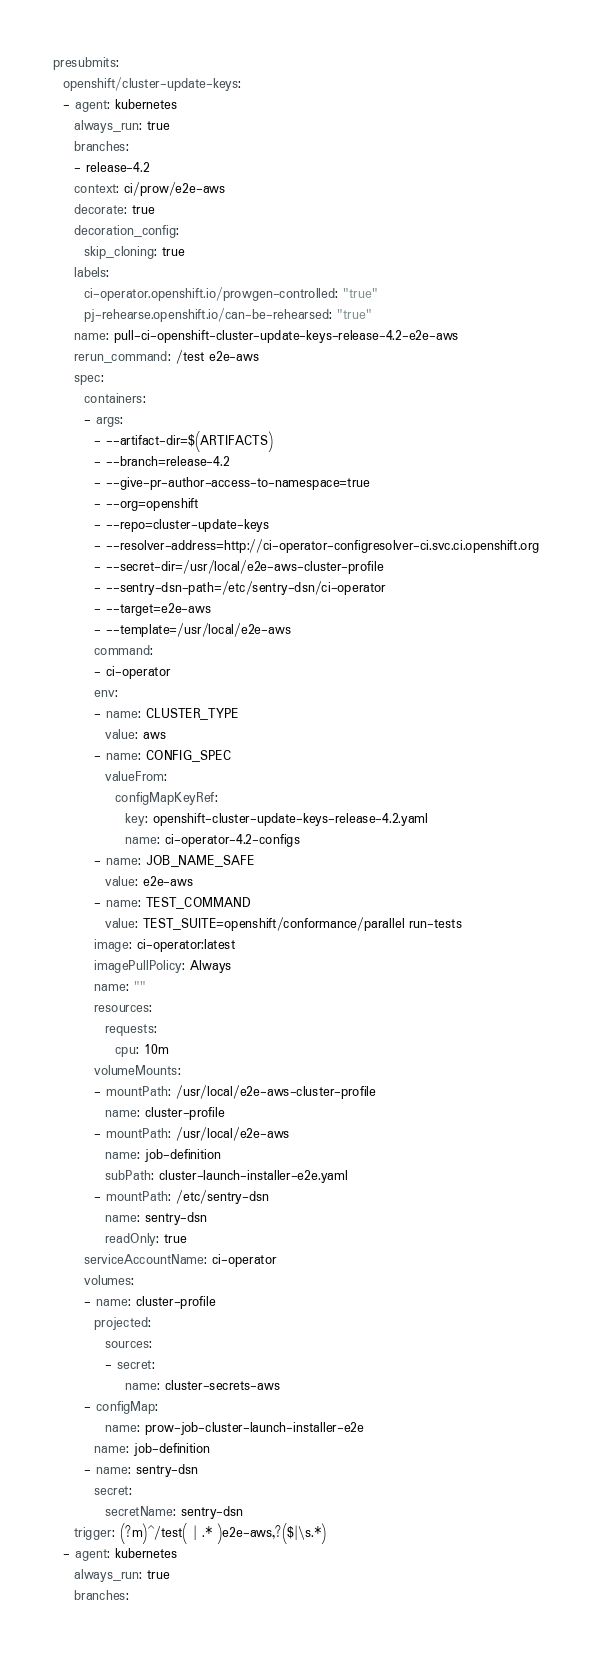Convert code to text. <code><loc_0><loc_0><loc_500><loc_500><_YAML_>presubmits:
  openshift/cluster-update-keys:
  - agent: kubernetes
    always_run: true
    branches:
    - release-4.2
    context: ci/prow/e2e-aws
    decorate: true
    decoration_config:
      skip_cloning: true
    labels:
      ci-operator.openshift.io/prowgen-controlled: "true"
      pj-rehearse.openshift.io/can-be-rehearsed: "true"
    name: pull-ci-openshift-cluster-update-keys-release-4.2-e2e-aws
    rerun_command: /test e2e-aws
    spec:
      containers:
      - args:
        - --artifact-dir=$(ARTIFACTS)
        - --branch=release-4.2
        - --give-pr-author-access-to-namespace=true
        - --org=openshift
        - --repo=cluster-update-keys
        - --resolver-address=http://ci-operator-configresolver-ci.svc.ci.openshift.org
        - --secret-dir=/usr/local/e2e-aws-cluster-profile
        - --sentry-dsn-path=/etc/sentry-dsn/ci-operator
        - --target=e2e-aws
        - --template=/usr/local/e2e-aws
        command:
        - ci-operator
        env:
        - name: CLUSTER_TYPE
          value: aws
        - name: CONFIG_SPEC
          valueFrom:
            configMapKeyRef:
              key: openshift-cluster-update-keys-release-4.2.yaml
              name: ci-operator-4.2-configs
        - name: JOB_NAME_SAFE
          value: e2e-aws
        - name: TEST_COMMAND
          value: TEST_SUITE=openshift/conformance/parallel run-tests
        image: ci-operator:latest
        imagePullPolicy: Always
        name: ""
        resources:
          requests:
            cpu: 10m
        volumeMounts:
        - mountPath: /usr/local/e2e-aws-cluster-profile
          name: cluster-profile
        - mountPath: /usr/local/e2e-aws
          name: job-definition
          subPath: cluster-launch-installer-e2e.yaml
        - mountPath: /etc/sentry-dsn
          name: sentry-dsn
          readOnly: true
      serviceAccountName: ci-operator
      volumes:
      - name: cluster-profile
        projected:
          sources:
          - secret:
              name: cluster-secrets-aws
      - configMap:
          name: prow-job-cluster-launch-installer-e2e
        name: job-definition
      - name: sentry-dsn
        secret:
          secretName: sentry-dsn
    trigger: (?m)^/test( | .* )e2e-aws,?($|\s.*)
  - agent: kubernetes
    always_run: true
    branches:</code> 